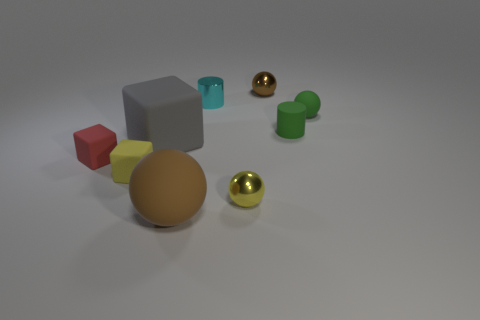Subtract all tiny matte cubes. How many cubes are left? 1 Subtract all yellow cubes. How many cubes are left? 2 Add 1 green spheres. How many objects exist? 10 Subtract 1 balls. How many balls are left? 3 Subtract all spheres. How many objects are left? 5 Subtract 1 cyan cylinders. How many objects are left? 8 Subtract all cyan cubes. Subtract all cyan cylinders. How many cubes are left? 3 Subtract all red cylinders. How many red cubes are left? 1 Subtract all yellow spheres. Subtract all red objects. How many objects are left? 7 Add 7 cylinders. How many cylinders are left? 9 